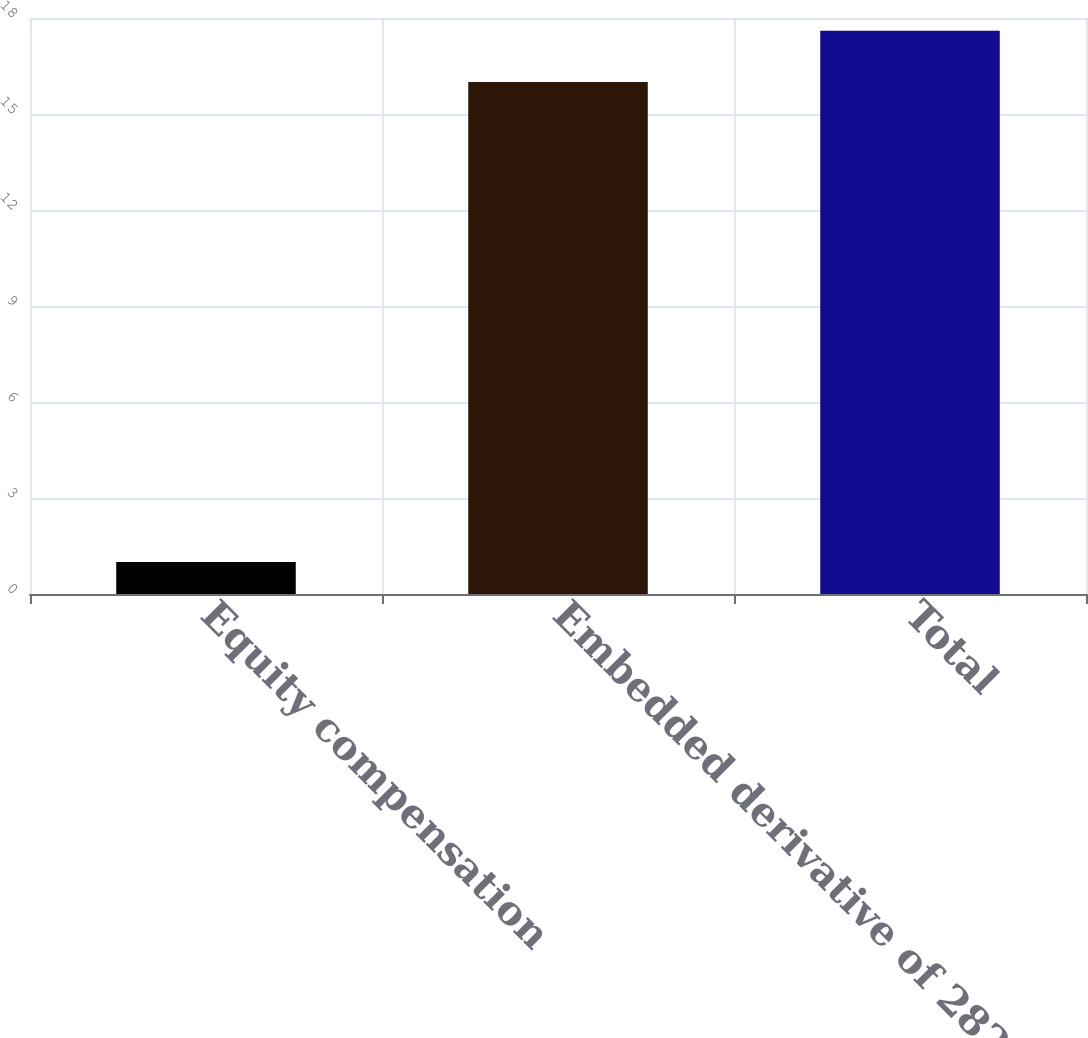Convert chart. <chart><loc_0><loc_0><loc_500><loc_500><bar_chart><fcel>Equity compensation<fcel>Embedded derivative of 2822<fcel>Total<nl><fcel>1<fcel>16<fcel>17.6<nl></chart> 